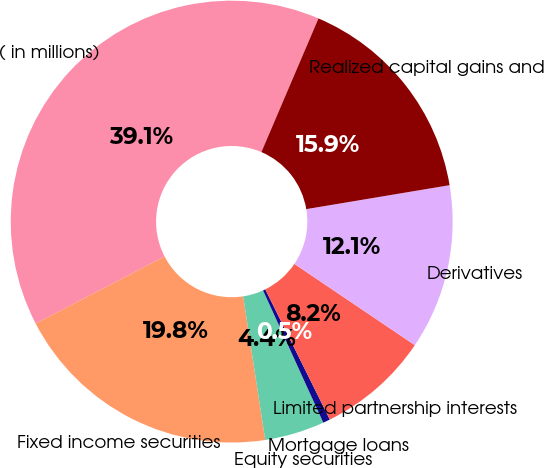<chart> <loc_0><loc_0><loc_500><loc_500><pie_chart><fcel>( in millions)<fcel>Fixed income securities<fcel>Equity securities<fcel>Mortgage loans<fcel>Limited partnership interests<fcel>Derivatives<fcel>Realized capital gains and<nl><fcel>39.06%<fcel>19.79%<fcel>4.38%<fcel>0.52%<fcel>8.23%<fcel>12.08%<fcel>15.94%<nl></chart> 